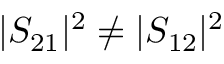<formula> <loc_0><loc_0><loc_500><loc_500>| S _ { 2 1 } | ^ { 2 } \neq | S _ { 1 2 } | ^ { 2 }</formula> 